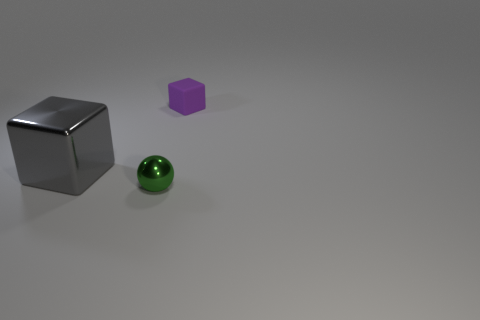Add 3 metal cubes. How many objects exist? 6 Subtract all balls. How many objects are left? 2 Add 2 small gray cylinders. How many small gray cylinders exist? 2 Subtract 1 gray blocks. How many objects are left? 2 Subtract all big brown shiny objects. Subtract all large shiny blocks. How many objects are left? 2 Add 3 purple matte objects. How many purple matte objects are left? 4 